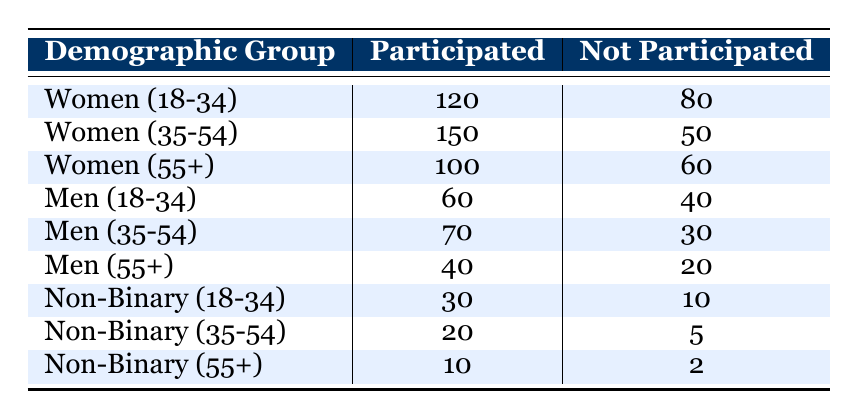What percentage of Women (35-54) participated in community service programs? To find the percentage, divide the number of participants (150) by the total number of respondents in that demographic group, which is the sum of participated and not participated (150 + 50 = 200). Therefore, the percentage is (150/200) * 100 = 75%.
Answer: 75% How many Non-Binary individuals aged 55+ did not participate in community service programs? According to the table, the number of Non-Binary individuals aged 55+ who did not participate is listed as 2.
Answer: 2 Which demographic group had the highest number of participants? By examining the table, Women (35-54) have the highest number of participants, with a total of 150.
Answer: Women (35-54) Did more Men (55+) participate than Non-Binary individuals (18-34)? For Men (55+), 40 participated, and for Non-Binary (18-34), 30 participated. Since 40 > 30, it is true that more Men (55+) participated than Non-Binary (18-34).
Answer: Yes What is the total number of individuals who participated across all demographic groups? To find the total number of participants across all groups, sum the participated values: 120 + 150 + 100 + 60 + 70 + 40 + 30 + 20 + 10 = 700.
Answer: 700 What is the average number of individuals that participated among the Non-Binary groups? To find the average, add the participants in the Non-Binary groups: 30 + 20 + 10 = 60. Then, divide by the number of Non-Binary groups (3), which gives an average of 60/3 = 20.
Answer: 20 Which age group has the least amount of participation when considering all genders? Looking closely, Non-Binary individuals aged 55+ have the least amount of participation, with only 10 participants.
Answer: Non-Binary (55+) Is it true that fewer than 100 Men participated in community service programs? For Men, the participation numbers are 60, 70, and 40, all summing less than 100. Therefore, it is true that fewer than 100 Men participated.
Answer: Yes 